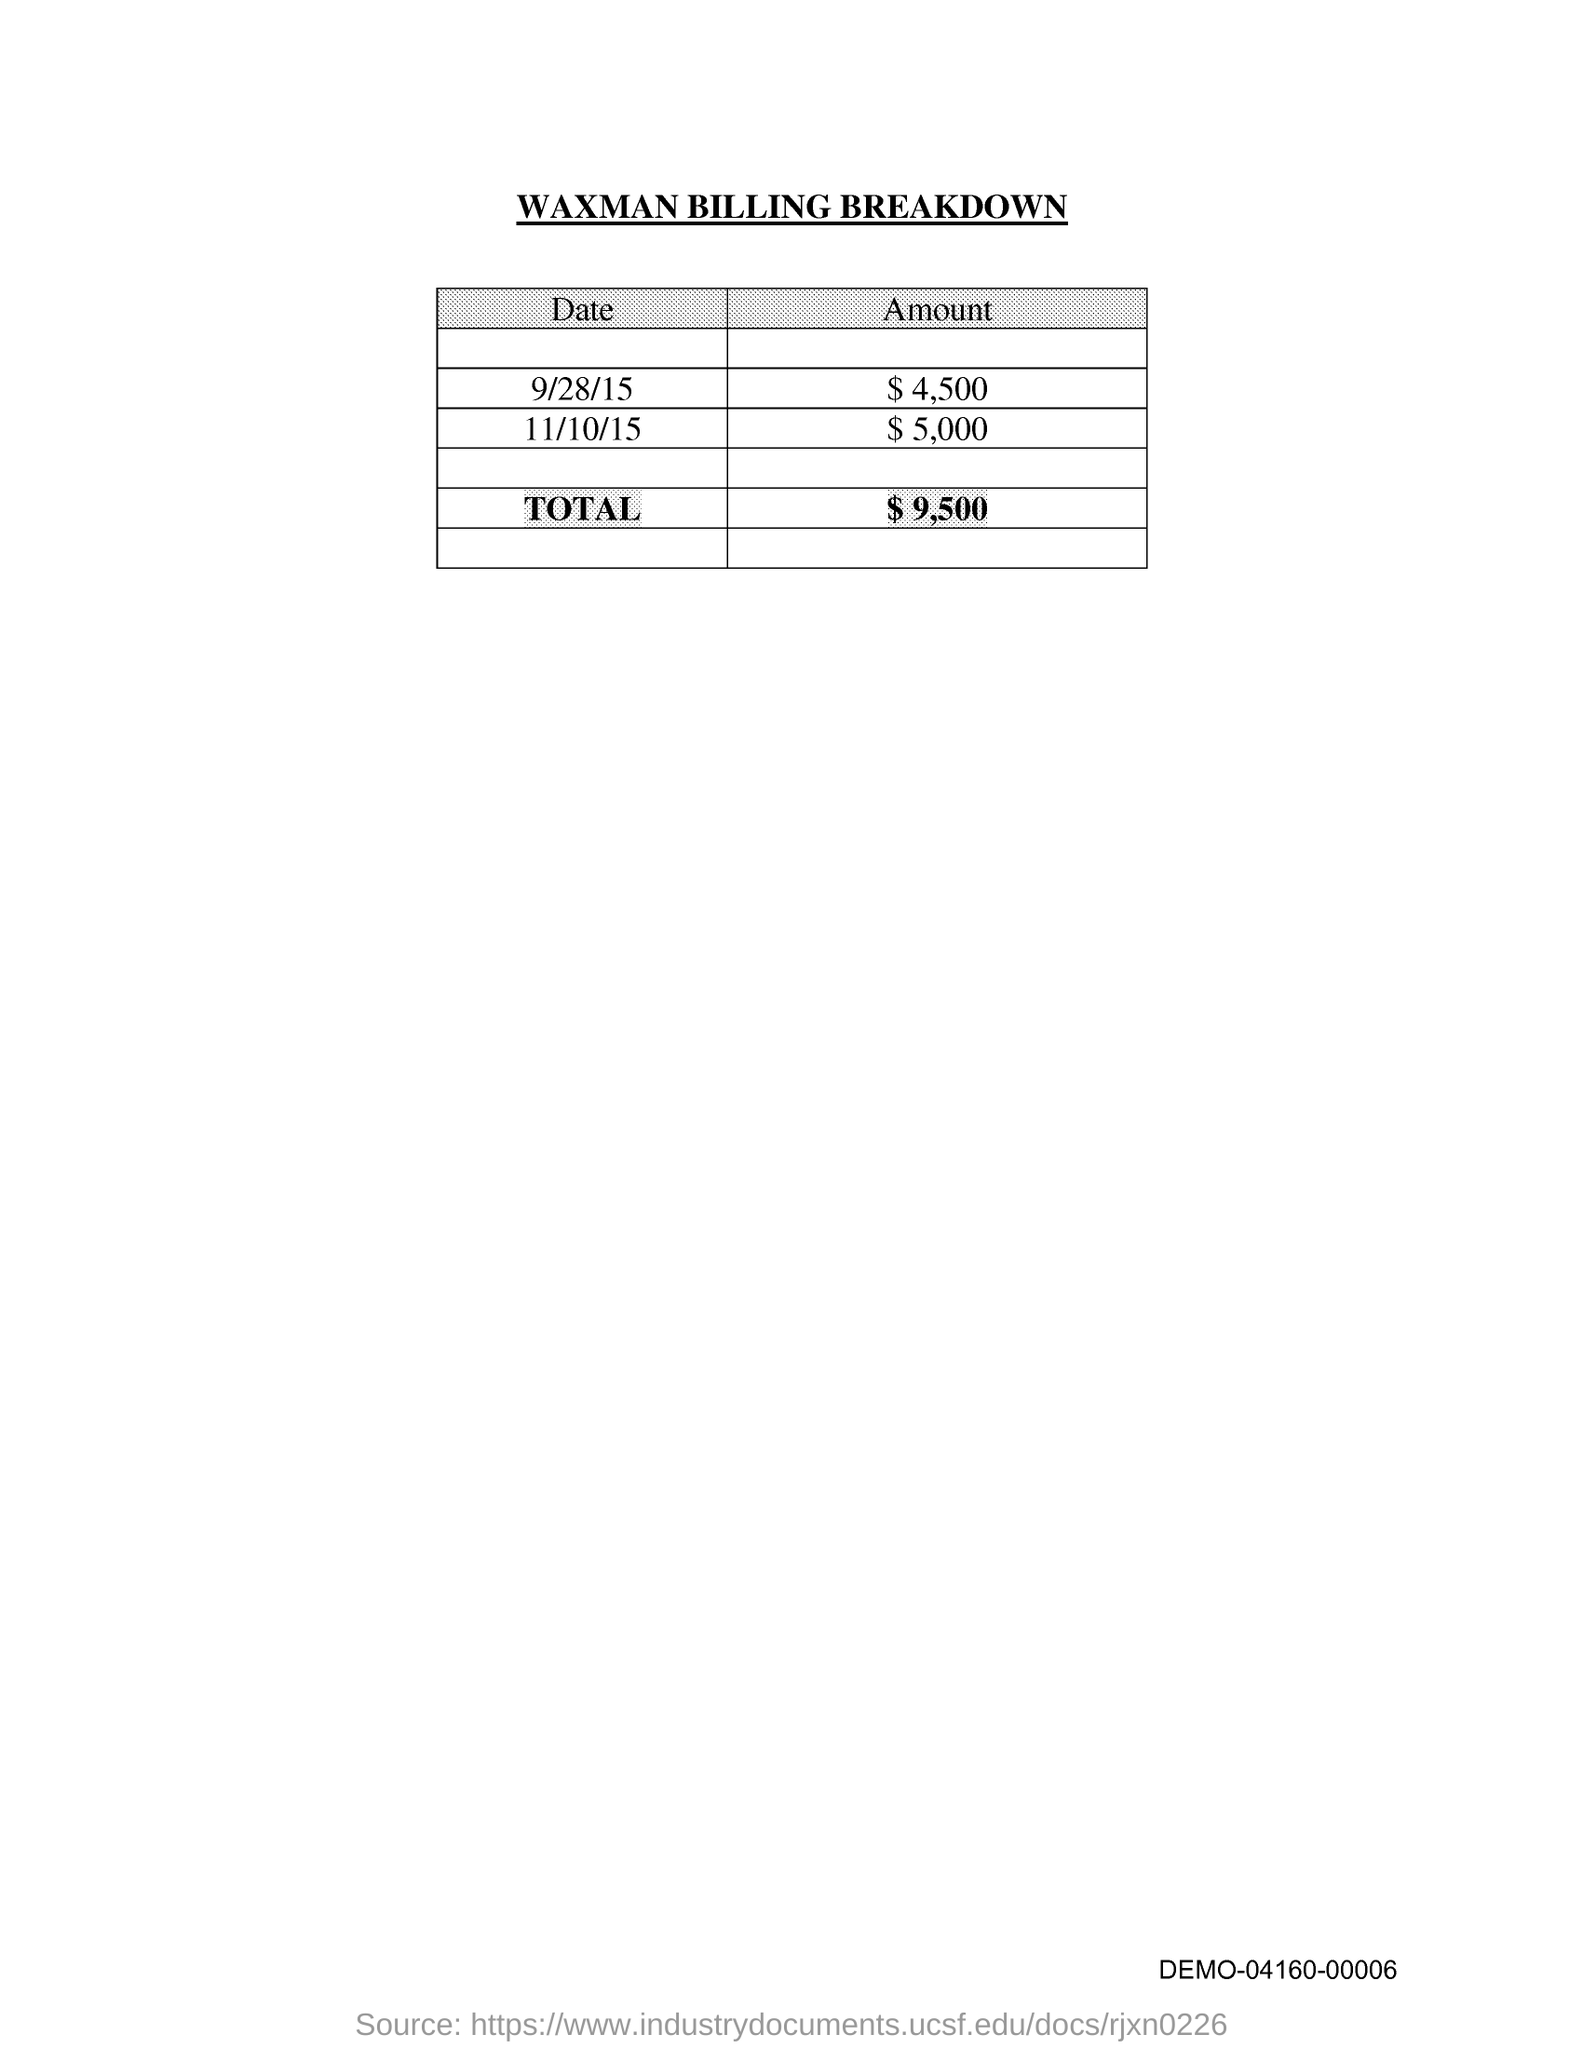Specify some key components in this picture. The amount of the bill on October 11, 2015, was $5,000. On September 28, 2015, the amount of the bill was $4,500. The document in question is titled "Waxman Billing Breakdown. 